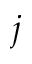Convert formula to latex. <formula><loc_0><loc_0><loc_500><loc_500>j</formula> 